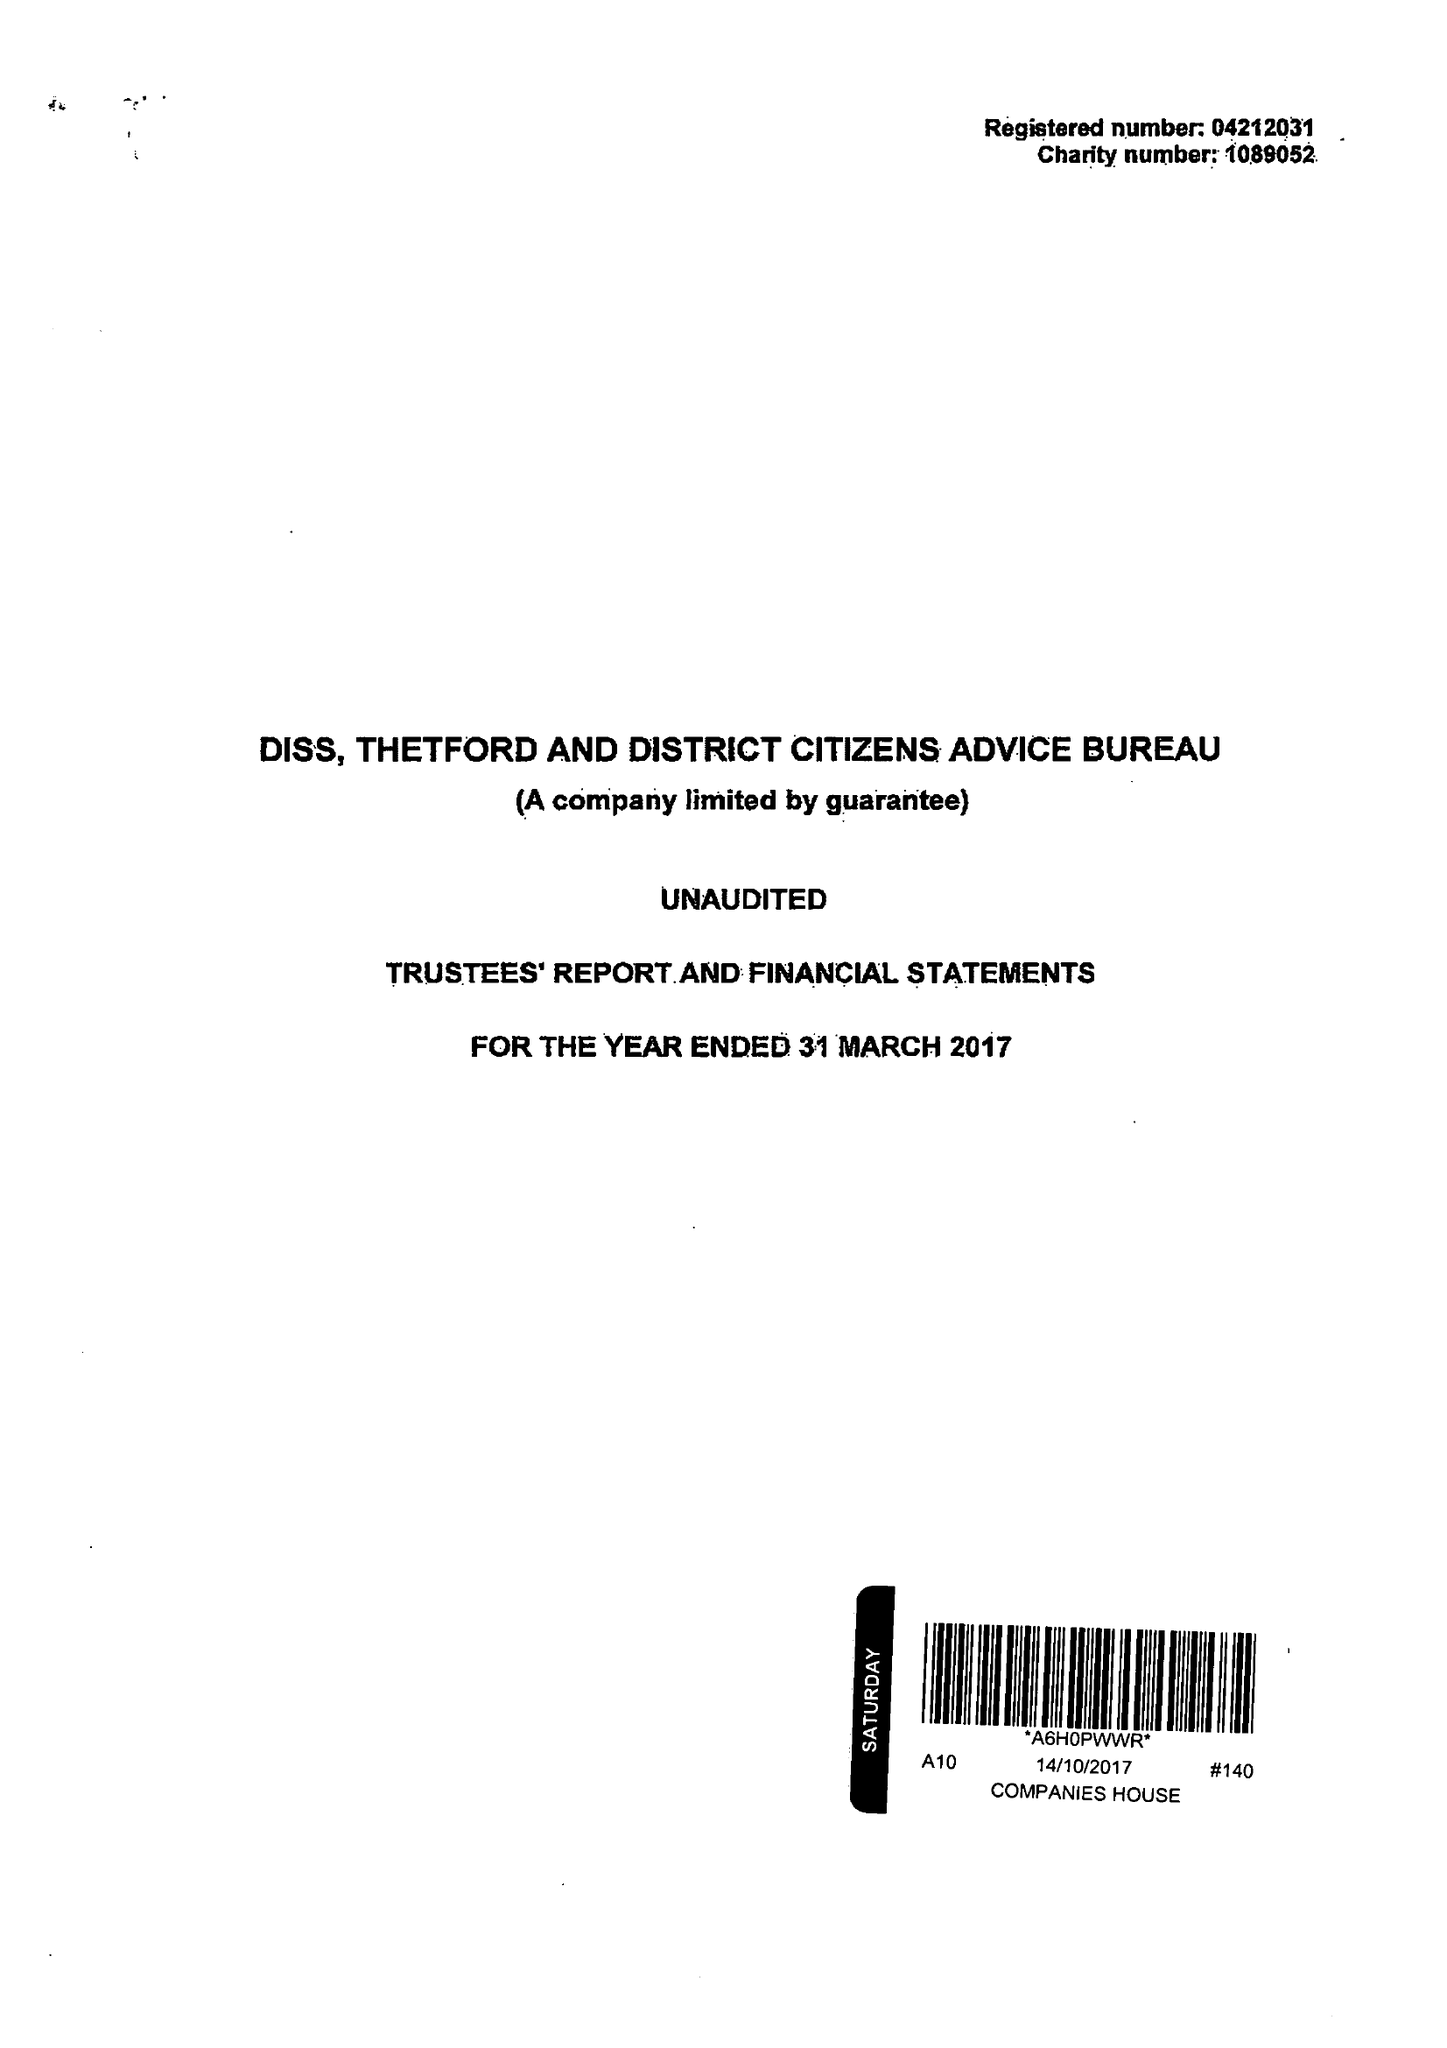What is the value for the address__postcode?
Answer the question using a single word or phrase. IP22 4EH 